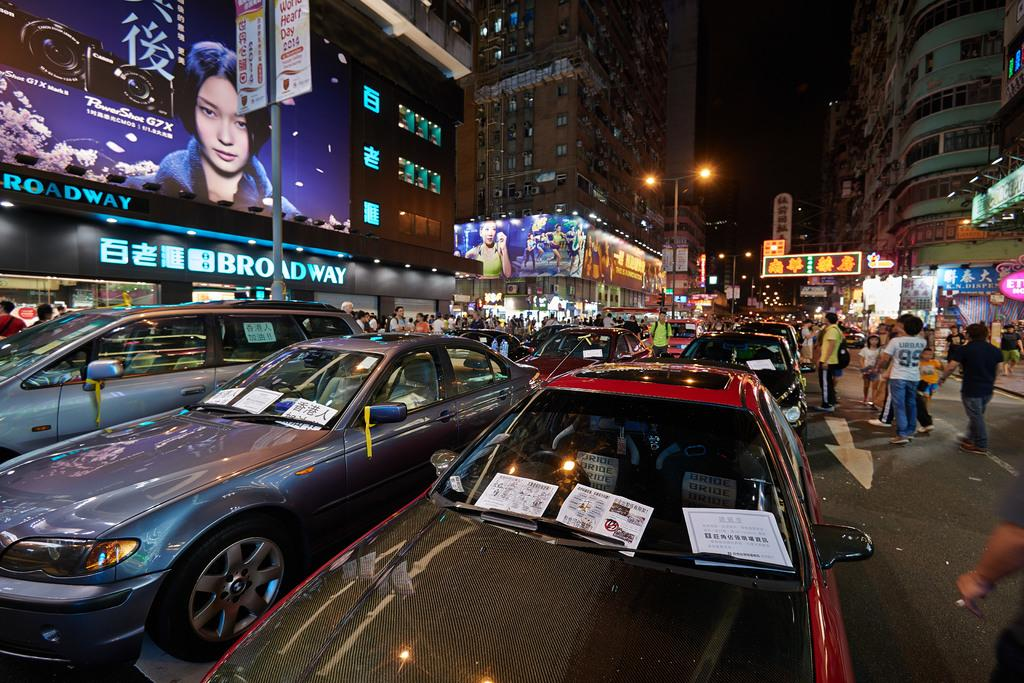<image>
Write a terse but informative summary of the picture. A busy, warm, evening  with several people looking at the Broadway billboard. 